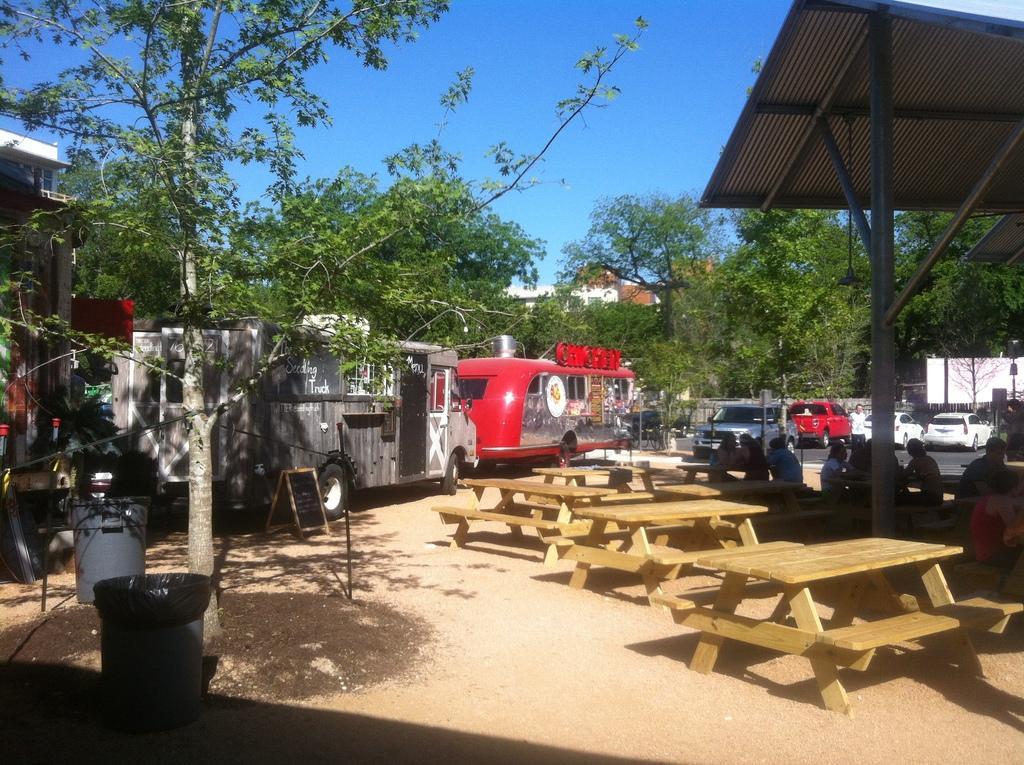In one or two sentences, can you explain what this image depicts? In this image we can see a few people are sitting on the bench. There is a table. At the back side there are vehicles,trees and a bin. 